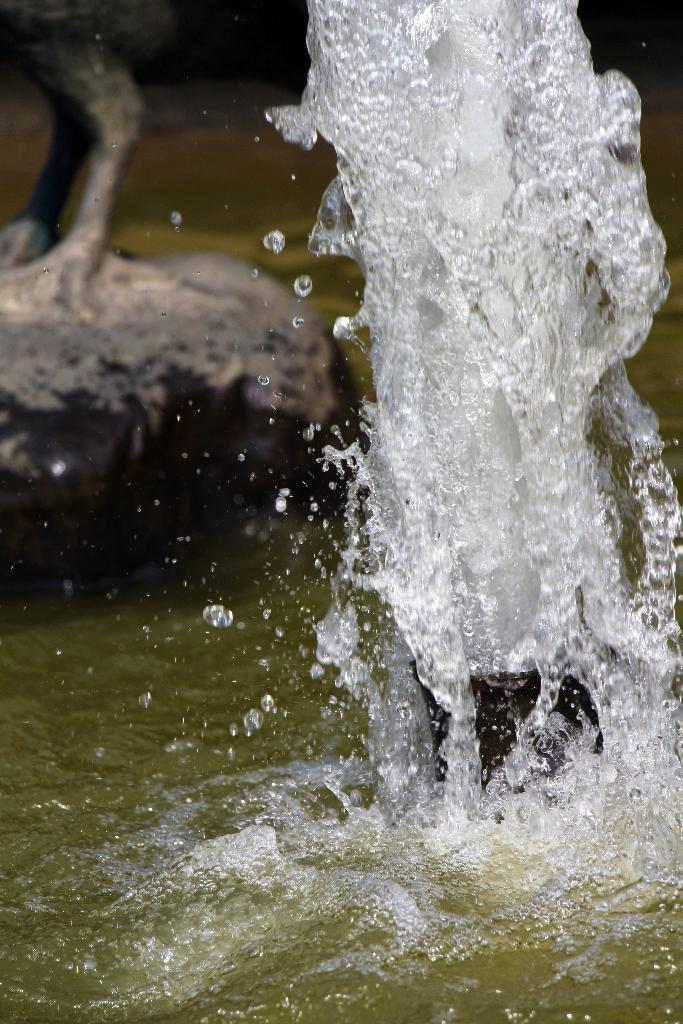What is the main object in the foreground of the image? There is a pump in the foreground of the image. What type of natural feature is at the bottom of the image? There is a lake at the bottom of the image. What can be seen in the background of the image? There is a rock and other objects in the background of the image. What type of parcel is being delivered to the rock in the background of the image? There is no parcel or delivery activity present in the image. Is there a baseball game taking place in the image? There is no baseball game or any reference to sports in the image. 